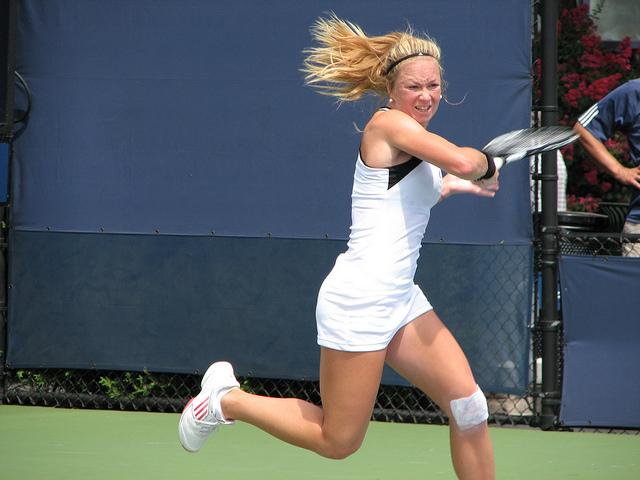Does she have a problem with her knee?
Answer briefly. Yes. Is she moving?
Be succinct. Yes. What color is the players top?
Concise answer only. White. 